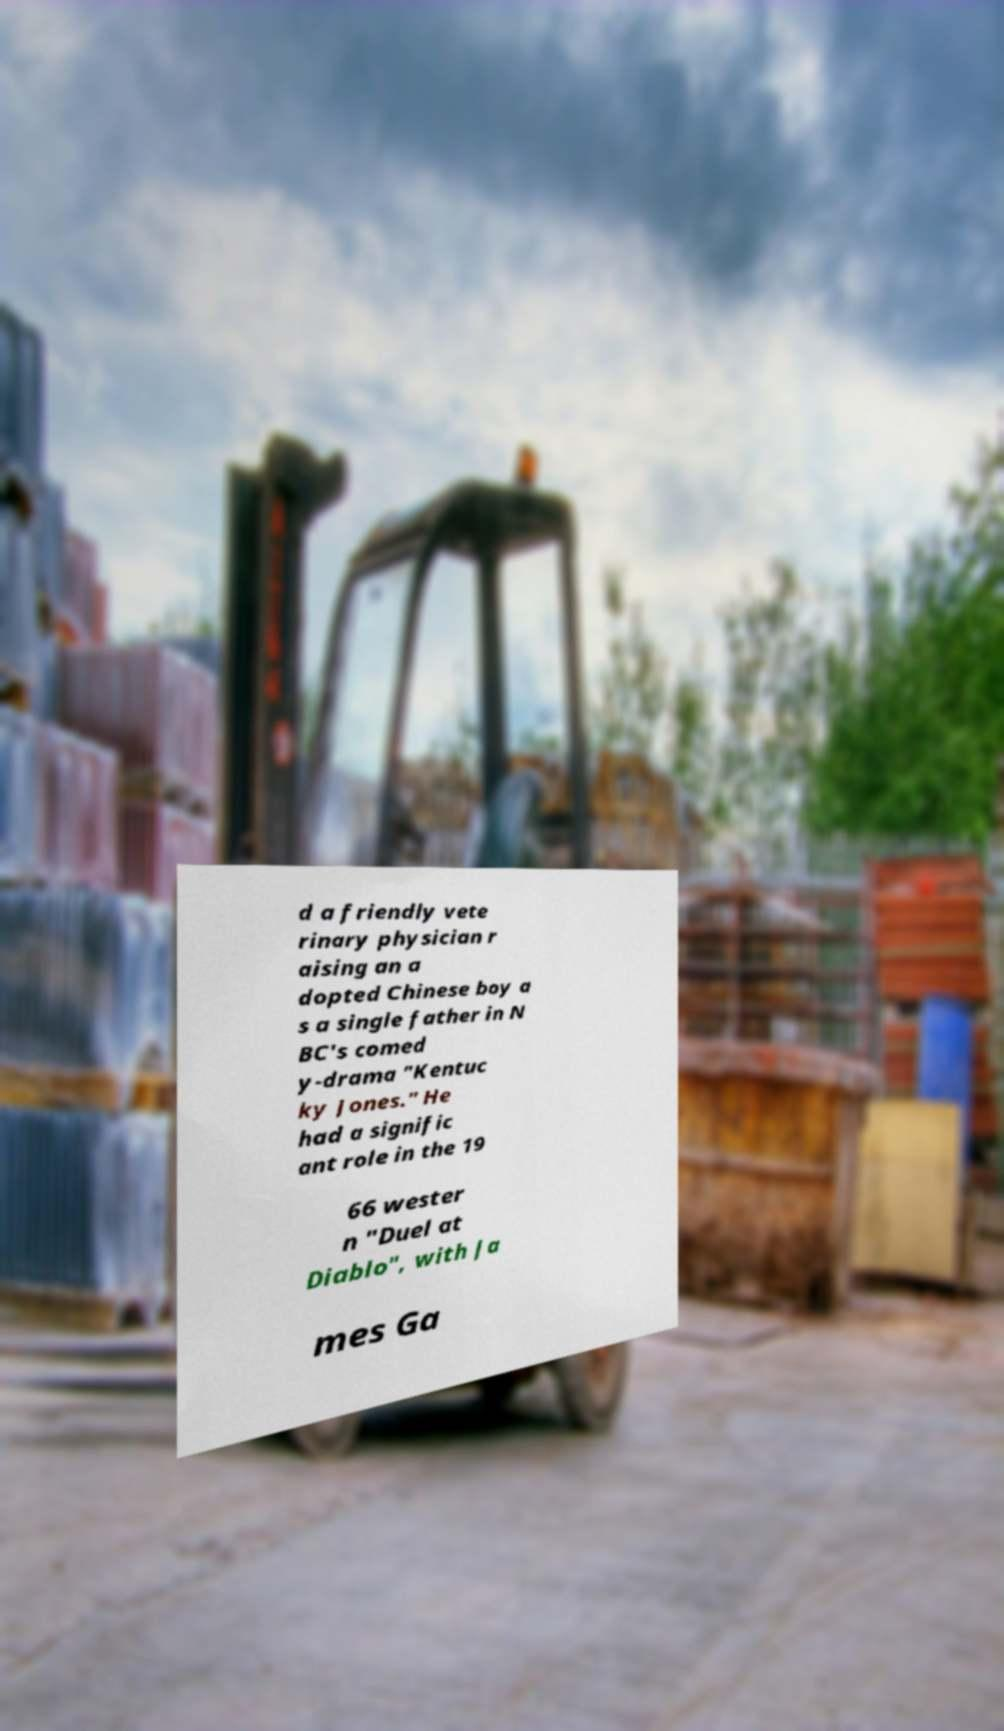Could you extract and type out the text from this image? d a friendly vete rinary physician r aising an a dopted Chinese boy a s a single father in N BC's comed y-drama "Kentuc ky Jones." He had a signific ant role in the 19 66 wester n "Duel at Diablo", with Ja mes Ga 